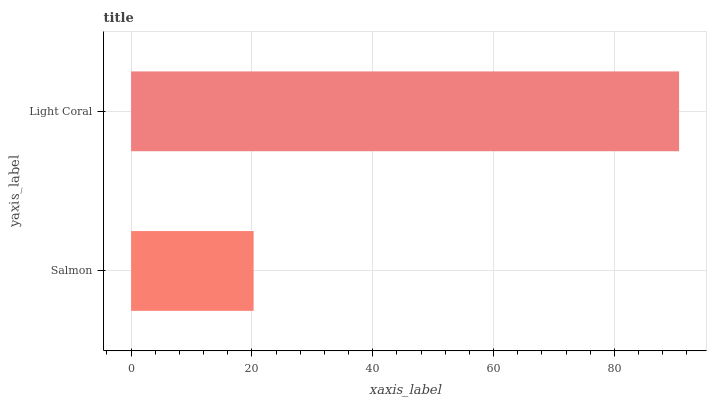Is Salmon the minimum?
Answer yes or no. Yes. Is Light Coral the maximum?
Answer yes or no. Yes. Is Light Coral the minimum?
Answer yes or no. No. Is Light Coral greater than Salmon?
Answer yes or no. Yes. Is Salmon less than Light Coral?
Answer yes or no. Yes. Is Salmon greater than Light Coral?
Answer yes or no. No. Is Light Coral less than Salmon?
Answer yes or no. No. Is Light Coral the high median?
Answer yes or no. Yes. Is Salmon the low median?
Answer yes or no. Yes. Is Salmon the high median?
Answer yes or no. No. Is Light Coral the low median?
Answer yes or no. No. 